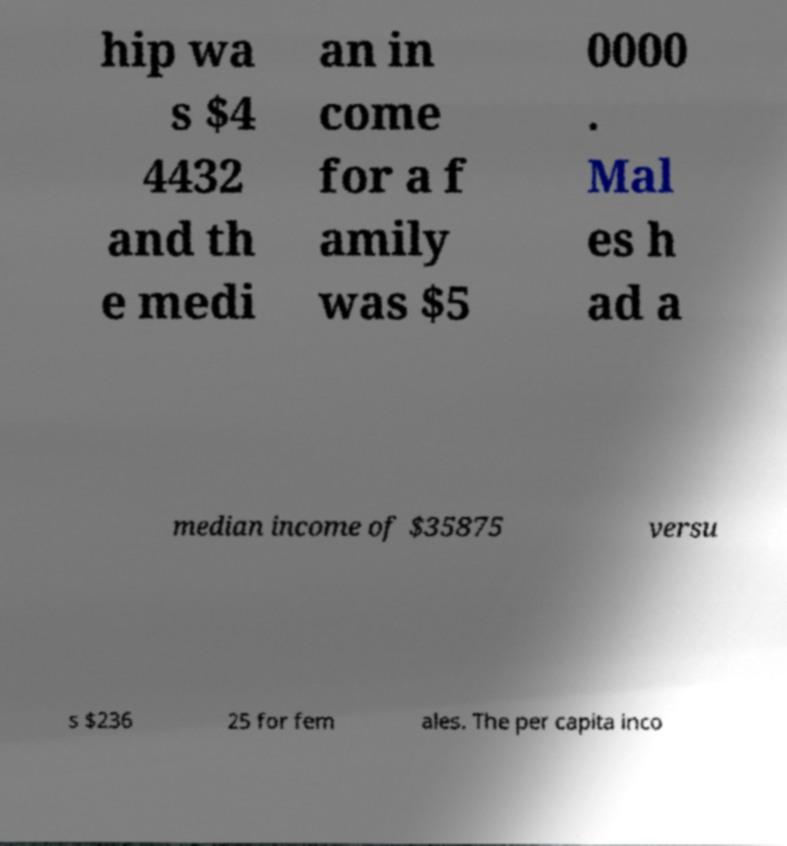Could you assist in decoding the text presented in this image and type it out clearly? hip wa s $4 4432 and th e medi an in come for a f amily was $5 0000 . Mal es h ad a median income of $35875 versu s $236 25 for fem ales. The per capita inco 